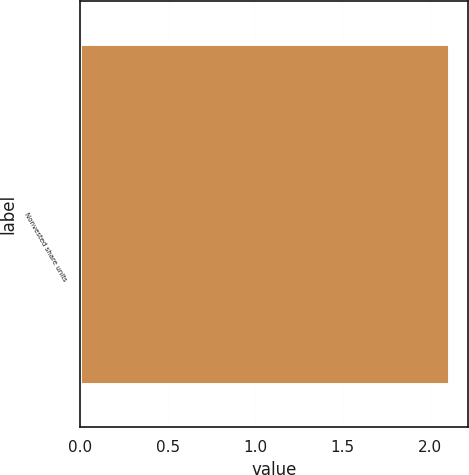<chart> <loc_0><loc_0><loc_500><loc_500><bar_chart><fcel>Nonvested share units<nl><fcel>2.11<nl></chart> 